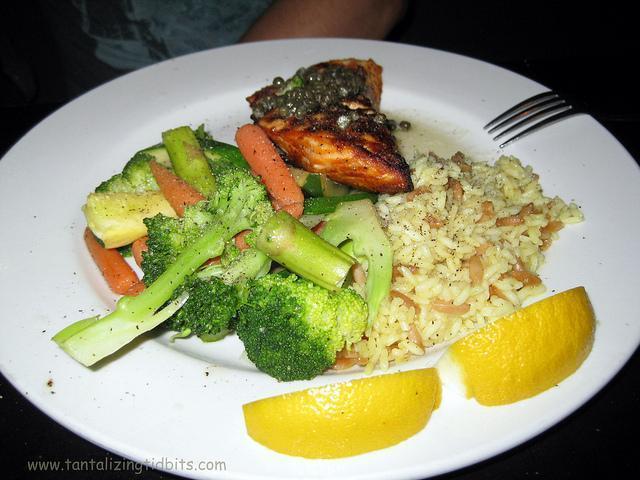What type of dish is this?
Answer the question by selecting the correct answer among the 4 following choices and explain your choice with a short sentence. The answer should be formatted with the following format: `Answer: choice
Rationale: rationale.`
Options: Dessert, side dish, entree, appetizer. Answer: entree.
Rationale: A plate of rice and vegetables is prepared and garnished with lemon wedges. 